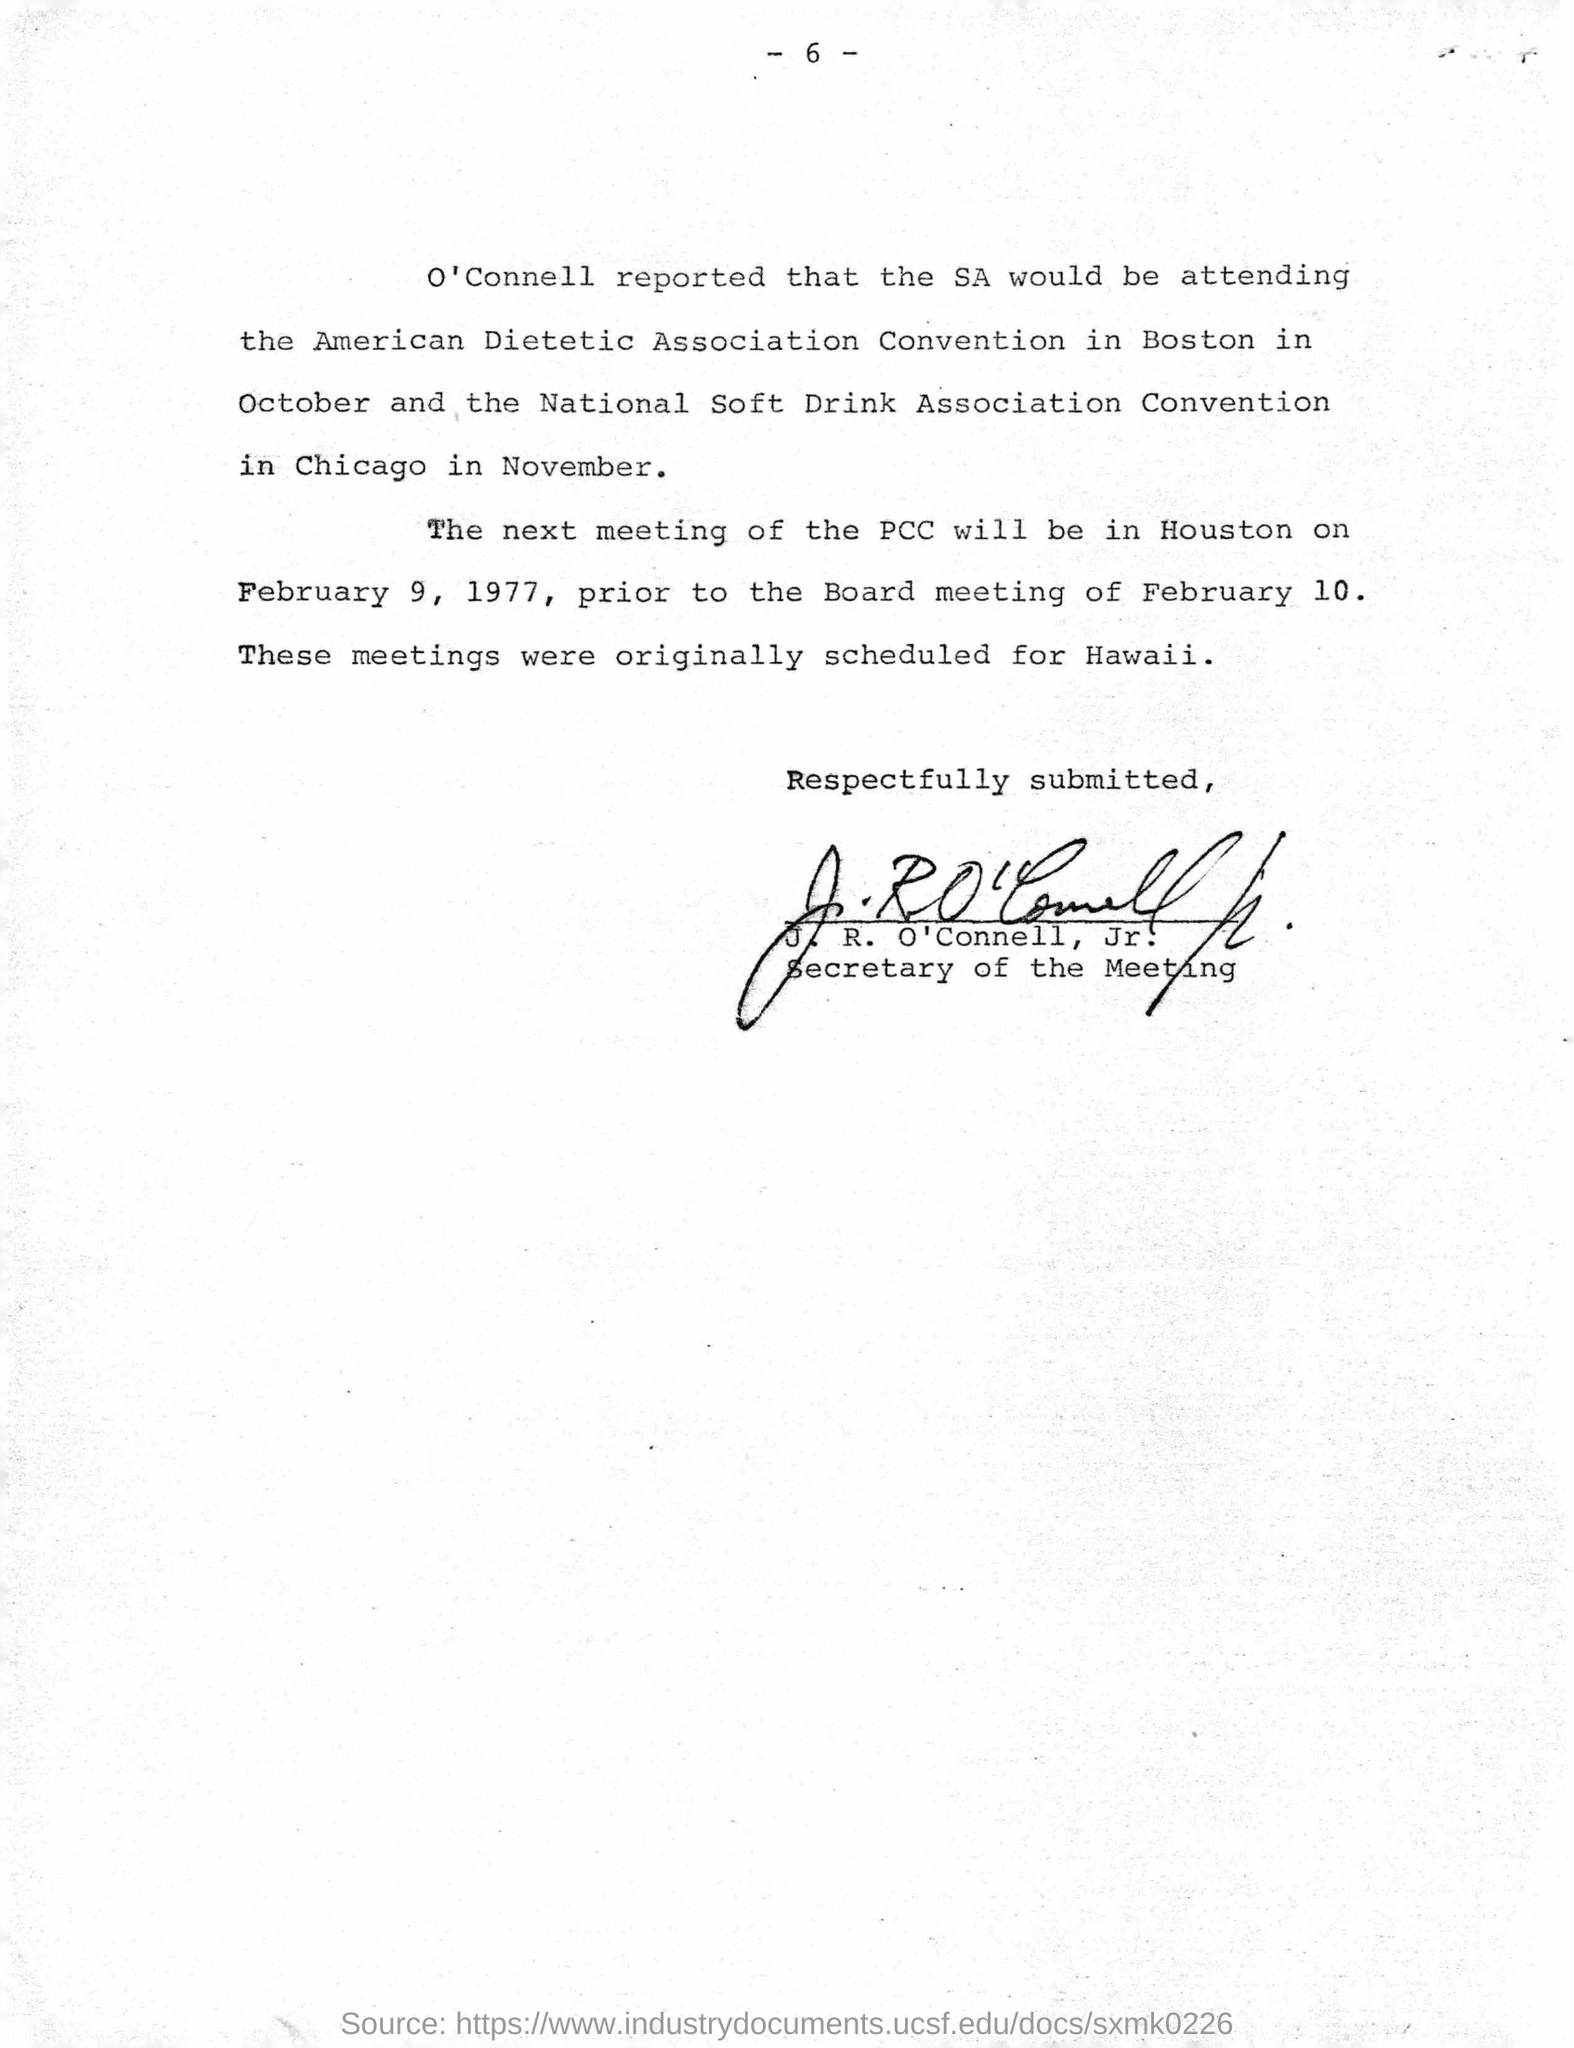Who reported that sa would be attending the covention?
Provide a short and direct response. O'Connell. Where is the american dietic association convention happeining?
Offer a very short reply. Boston. Where is the national soft drink association convention happening?
Provide a succinct answer. Chicago. In which month is the american dietic association convention happening?
Ensure brevity in your answer.  October. In which month is the national soft drink association convention happening?
Provide a short and direct response. November. Where will be the next meeting of the pcc be held?
Make the answer very short. Houston. When will be the next meeting of pcc held?
Provide a succinct answer. February 9, 1977. When is the board meeting?
Your response must be concise. February 10. For which place were these meetings originally scheduled?
Keep it short and to the point. Hawaii. Who has signed the document?
Make the answer very short. J. R. O'Connell, Jr. What is the designation of j. r. o'connell?
Give a very brief answer. Secretary of the Meeting. 